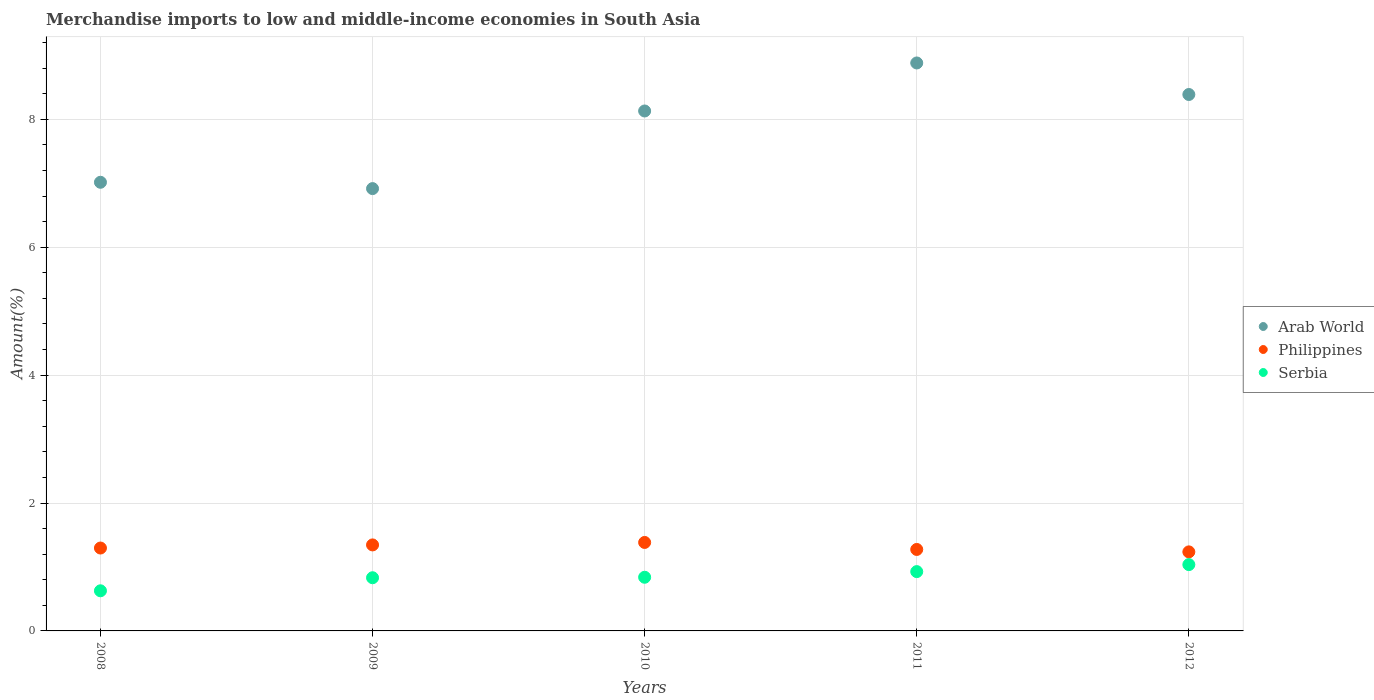How many different coloured dotlines are there?
Ensure brevity in your answer.  3. Is the number of dotlines equal to the number of legend labels?
Your answer should be compact. Yes. What is the percentage of amount earned from merchandise imports in Arab World in 2010?
Your answer should be compact. 8.13. Across all years, what is the maximum percentage of amount earned from merchandise imports in Arab World?
Keep it short and to the point. 8.88. Across all years, what is the minimum percentage of amount earned from merchandise imports in Serbia?
Your answer should be compact. 0.63. In which year was the percentage of amount earned from merchandise imports in Philippines maximum?
Offer a terse response. 2010. What is the total percentage of amount earned from merchandise imports in Arab World in the graph?
Your response must be concise. 39.33. What is the difference between the percentage of amount earned from merchandise imports in Philippines in 2009 and that in 2010?
Your answer should be compact. -0.04. What is the difference between the percentage of amount earned from merchandise imports in Philippines in 2010 and the percentage of amount earned from merchandise imports in Arab World in 2008?
Your answer should be compact. -5.63. What is the average percentage of amount earned from merchandise imports in Arab World per year?
Offer a very short reply. 7.87. In the year 2011, what is the difference between the percentage of amount earned from merchandise imports in Philippines and percentage of amount earned from merchandise imports in Serbia?
Make the answer very short. 0.35. What is the ratio of the percentage of amount earned from merchandise imports in Arab World in 2008 to that in 2009?
Keep it short and to the point. 1.01. Is the percentage of amount earned from merchandise imports in Philippines in 2008 less than that in 2011?
Give a very brief answer. No. Is the difference between the percentage of amount earned from merchandise imports in Philippines in 2008 and 2009 greater than the difference between the percentage of amount earned from merchandise imports in Serbia in 2008 and 2009?
Make the answer very short. Yes. What is the difference between the highest and the second highest percentage of amount earned from merchandise imports in Serbia?
Provide a succinct answer. 0.11. What is the difference between the highest and the lowest percentage of amount earned from merchandise imports in Philippines?
Make the answer very short. 0.15. Is the sum of the percentage of amount earned from merchandise imports in Philippines in 2008 and 2009 greater than the maximum percentage of amount earned from merchandise imports in Arab World across all years?
Make the answer very short. No. Is it the case that in every year, the sum of the percentage of amount earned from merchandise imports in Philippines and percentage of amount earned from merchandise imports in Arab World  is greater than the percentage of amount earned from merchandise imports in Serbia?
Provide a short and direct response. Yes. How many dotlines are there?
Make the answer very short. 3. What is the difference between two consecutive major ticks on the Y-axis?
Give a very brief answer. 2. Does the graph contain any zero values?
Make the answer very short. No. Where does the legend appear in the graph?
Provide a short and direct response. Center right. How many legend labels are there?
Provide a succinct answer. 3. What is the title of the graph?
Give a very brief answer. Merchandise imports to low and middle-income economies in South Asia. What is the label or title of the X-axis?
Your answer should be compact. Years. What is the label or title of the Y-axis?
Provide a short and direct response. Amount(%). What is the Amount(%) of Arab World in 2008?
Offer a very short reply. 7.01. What is the Amount(%) in Philippines in 2008?
Keep it short and to the point. 1.3. What is the Amount(%) of Serbia in 2008?
Offer a terse response. 0.63. What is the Amount(%) of Arab World in 2009?
Provide a short and direct response. 6.92. What is the Amount(%) in Philippines in 2009?
Ensure brevity in your answer.  1.34. What is the Amount(%) of Serbia in 2009?
Make the answer very short. 0.83. What is the Amount(%) of Arab World in 2010?
Your answer should be very brief. 8.13. What is the Amount(%) of Philippines in 2010?
Your response must be concise. 1.38. What is the Amount(%) in Serbia in 2010?
Make the answer very short. 0.84. What is the Amount(%) in Arab World in 2011?
Give a very brief answer. 8.88. What is the Amount(%) of Philippines in 2011?
Your response must be concise. 1.27. What is the Amount(%) of Serbia in 2011?
Provide a short and direct response. 0.93. What is the Amount(%) of Arab World in 2012?
Ensure brevity in your answer.  8.39. What is the Amount(%) in Philippines in 2012?
Provide a succinct answer. 1.24. What is the Amount(%) in Serbia in 2012?
Provide a succinct answer. 1.04. Across all years, what is the maximum Amount(%) of Arab World?
Keep it short and to the point. 8.88. Across all years, what is the maximum Amount(%) of Philippines?
Your answer should be very brief. 1.38. Across all years, what is the maximum Amount(%) in Serbia?
Ensure brevity in your answer.  1.04. Across all years, what is the minimum Amount(%) in Arab World?
Provide a short and direct response. 6.92. Across all years, what is the minimum Amount(%) of Philippines?
Make the answer very short. 1.24. Across all years, what is the minimum Amount(%) of Serbia?
Give a very brief answer. 0.63. What is the total Amount(%) of Arab World in the graph?
Provide a succinct answer. 39.33. What is the total Amount(%) of Philippines in the graph?
Your answer should be compact. 6.53. What is the total Amount(%) in Serbia in the graph?
Offer a very short reply. 4.26. What is the difference between the Amount(%) in Arab World in 2008 and that in 2009?
Your answer should be very brief. 0.1. What is the difference between the Amount(%) of Philippines in 2008 and that in 2009?
Keep it short and to the point. -0.05. What is the difference between the Amount(%) of Serbia in 2008 and that in 2009?
Make the answer very short. -0.2. What is the difference between the Amount(%) in Arab World in 2008 and that in 2010?
Ensure brevity in your answer.  -1.11. What is the difference between the Amount(%) of Philippines in 2008 and that in 2010?
Keep it short and to the point. -0.09. What is the difference between the Amount(%) in Serbia in 2008 and that in 2010?
Offer a very short reply. -0.21. What is the difference between the Amount(%) in Arab World in 2008 and that in 2011?
Provide a succinct answer. -1.87. What is the difference between the Amount(%) in Philippines in 2008 and that in 2011?
Your answer should be very brief. 0.02. What is the difference between the Amount(%) of Arab World in 2008 and that in 2012?
Provide a short and direct response. -1.37. What is the difference between the Amount(%) of Philippines in 2008 and that in 2012?
Offer a very short reply. 0.06. What is the difference between the Amount(%) in Serbia in 2008 and that in 2012?
Keep it short and to the point. -0.41. What is the difference between the Amount(%) in Arab World in 2009 and that in 2010?
Make the answer very short. -1.21. What is the difference between the Amount(%) in Philippines in 2009 and that in 2010?
Offer a terse response. -0.04. What is the difference between the Amount(%) in Serbia in 2009 and that in 2010?
Your answer should be compact. -0.01. What is the difference between the Amount(%) of Arab World in 2009 and that in 2011?
Keep it short and to the point. -1.96. What is the difference between the Amount(%) in Philippines in 2009 and that in 2011?
Make the answer very short. 0.07. What is the difference between the Amount(%) in Serbia in 2009 and that in 2011?
Your response must be concise. -0.1. What is the difference between the Amount(%) of Arab World in 2009 and that in 2012?
Your answer should be very brief. -1.47. What is the difference between the Amount(%) of Philippines in 2009 and that in 2012?
Your response must be concise. 0.11. What is the difference between the Amount(%) of Serbia in 2009 and that in 2012?
Your answer should be compact. -0.21. What is the difference between the Amount(%) in Arab World in 2010 and that in 2011?
Ensure brevity in your answer.  -0.75. What is the difference between the Amount(%) in Philippines in 2010 and that in 2011?
Your answer should be very brief. 0.11. What is the difference between the Amount(%) in Serbia in 2010 and that in 2011?
Give a very brief answer. -0.09. What is the difference between the Amount(%) of Arab World in 2010 and that in 2012?
Provide a succinct answer. -0.26. What is the difference between the Amount(%) of Philippines in 2010 and that in 2012?
Your response must be concise. 0.15. What is the difference between the Amount(%) of Serbia in 2010 and that in 2012?
Your answer should be compact. -0.2. What is the difference between the Amount(%) of Arab World in 2011 and that in 2012?
Offer a very short reply. 0.49. What is the difference between the Amount(%) of Philippines in 2011 and that in 2012?
Your answer should be compact. 0.04. What is the difference between the Amount(%) in Serbia in 2011 and that in 2012?
Ensure brevity in your answer.  -0.11. What is the difference between the Amount(%) in Arab World in 2008 and the Amount(%) in Philippines in 2009?
Make the answer very short. 5.67. What is the difference between the Amount(%) in Arab World in 2008 and the Amount(%) in Serbia in 2009?
Make the answer very short. 6.18. What is the difference between the Amount(%) of Philippines in 2008 and the Amount(%) of Serbia in 2009?
Provide a succinct answer. 0.46. What is the difference between the Amount(%) of Arab World in 2008 and the Amount(%) of Philippines in 2010?
Provide a succinct answer. 5.63. What is the difference between the Amount(%) of Arab World in 2008 and the Amount(%) of Serbia in 2010?
Offer a very short reply. 6.18. What is the difference between the Amount(%) of Philippines in 2008 and the Amount(%) of Serbia in 2010?
Keep it short and to the point. 0.46. What is the difference between the Amount(%) in Arab World in 2008 and the Amount(%) in Philippines in 2011?
Keep it short and to the point. 5.74. What is the difference between the Amount(%) in Arab World in 2008 and the Amount(%) in Serbia in 2011?
Make the answer very short. 6.09. What is the difference between the Amount(%) of Philippines in 2008 and the Amount(%) of Serbia in 2011?
Make the answer very short. 0.37. What is the difference between the Amount(%) in Arab World in 2008 and the Amount(%) in Philippines in 2012?
Your answer should be compact. 5.78. What is the difference between the Amount(%) in Arab World in 2008 and the Amount(%) in Serbia in 2012?
Your answer should be very brief. 5.98. What is the difference between the Amount(%) of Philippines in 2008 and the Amount(%) of Serbia in 2012?
Keep it short and to the point. 0.26. What is the difference between the Amount(%) in Arab World in 2009 and the Amount(%) in Philippines in 2010?
Provide a short and direct response. 5.53. What is the difference between the Amount(%) in Arab World in 2009 and the Amount(%) in Serbia in 2010?
Your answer should be compact. 6.08. What is the difference between the Amount(%) of Philippines in 2009 and the Amount(%) of Serbia in 2010?
Ensure brevity in your answer.  0.51. What is the difference between the Amount(%) in Arab World in 2009 and the Amount(%) in Philippines in 2011?
Give a very brief answer. 5.64. What is the difference between the Amount(%) of Arab World in 2009 and the Amount(%) of Serbia in 2011?
Provide a short and direct response. 5.99. What is the difference between the Amount(%) in Philippines in 2009 and the Amount(%) in Serbia in 2011?
Provide a short and direct response. 0.42. What is the difference between the Amount(%) in Arab World in 2009 and the Amount(%) in Philippines in 2012?
Give a very brief answer. 5.68. What is the difference between the Amount(%) of Arab World in 2009 and the Amount(%) of Serbia in 2012?
Your answer should be compact. 5.88. What is the difference between the Amount(%) in Philippines in 2009 and the Amount(%) in Serbia in 2012?
Make the answer very short. 0.31. What is the difference between the Amount(%) in Arab World in 2010 and the Amount(%) in Philippines in 2011?
Make the answer very short. 6.86. What is the difference between the Amount(%) in Arab World in 2010 and the Amount(%) in Serbia in 2011?
Provide a short and direct response. 7.2. What is the difference between the Amount(%) of Philippines in 2010 and the Amount(%) of Serbia in 2011?
Give a very brief answer. 0.46. What is the difference between the Amount(%) in Arab World in 2010 and the Amount(%) in Philippines in 2012?
Your response must be concise. 6.89. What is the difference between the Amount(%) of Arab World in 2010 and the Amount(%) of Serbia in 2012?
Ensure brevity in your answer.  7.09. What is the difference between the Amount(%) in Philippines in 2010 and the Amount(%) in Serbia in 2012?
Offer a terse response. 0.35. What is the difference between the Amount(%) in Arab World in 2011 and the Amount(%) in Philippines in 2012?
Offer a very short reply. 7.64. What is the difference between the Amount(%) of Arab World in 2011 and the Amount(%) of Serbia in 2012?
Keep it short and to the point. 7.84. What is the difference between the Amount(%) in Philippines in 2011 and the Amount(%) in Serbia in 2012?
Offer a very short reply. 0.24. What is the average Amount(%) of Arab World per year?
Your answer should be compact. 7.87. What is the average Amount(%) in Philippines per year?
Provide a short and direct response. 1.31. What is the average Amount(%) in Serbia per year?
Your answer should be compact. 0.85. In the year 2008, what is the difference between the Amount(%) in Arab World and Amount(%) in Philippines?
Your response must be concise. 5.72. In the year 2008, what is the difference between the Amount(%) of Arab World and Amount(%) of Serbia?
Keep it short and to the point. 6.39. In the year 2008, what is the difference between the Amount(%) of Philippines and Amount(%) of Serbia?
Keep it short and to the point. 0.67. In the year 2009, what is the difference between the Amount(%) of Arab World and Amount(%) of Philippines?
Keep it short and to the point. 5.57. In the year 2009, what is the difference between the Amount(%) in Arab World and Amount(%) in Serbia?
Ensure brevity in your answer.  6.08. In the year 2009, what is the difference between the Amount(%) of Philippines and Amount(%) of Serbia?
Ensure brevity in your answer.  0.51. In the year 2010, what is the difference between the Amount(%) in Arab World and Amount(%) in Philippines?
Offer a terse response. 6.75. In the year 2010, what is the difference between the Amount(%) in Arab World and Amount(%) in Serbia?
Provide a short and direct response. 7.29. In the year 2010, what is the difference between the Amount(%) in Philippines and Amount(%) in Serbia?
Offer a very short reply. 0.54. In the year 2011, what is the difference between the Amount(%) of Arab World and Amount(%) of Philippines?
Provide a short and direct response. 7.61. In the year 2011, what is the difference between the Amount(%) in Arab World and Amount(%) in Serbia?
Provide a succinct answer. 7.95. In the year 2011, what is the difference between the Amount(%) in Philippines and Amount(%) in Serbia?
Offer a terse response. 0.35. In the year 2012, what is the difference between the Amount(%) in Arab World and Amount(%) in Philippines?
Your answer should be compact. 7.15. In the year 2012, what is the difference between the Amount(%) of Arab World and Amount(%) of Serbia?
Your answer should be very brief. 7.35. In the year 2012, what is the difference between the Amount(%) in Philippines and Amount(%) in Serbia?
Provide a short and direct response. 0.2. What is the ratio of the Amount(%) of Arab World in 2008 to that in 2009?
Offer a terse response. 1.01. What is the ratio of the Amount(%) of Philippines in 2008 to that in 2009?
Your answer should be very brief. 0.96. What is the ratio of the Amount(%) in Serbia in 2008 to that in 2009?
Provide a short and direct response. 0.75. What is the ratio of the Amount(%) of Arab World in 2008 to that in 2010?
Ensure brevity in your answer.  0.86. What is the ratio of the Amount(%) in Philippines in 2008 to that in 2010?
Make the answer very short. 0.94. What is the ratio of the Amount(%) in Serbia in 2008 to that in 2010?
Offer a very short reply. 0.75. What is the ratio of the Amount(%) of Arab World in 2008 to that in 2011?
Offer a terse response. 0.79. What is the ratio of the Amount(%) of Philippines in 2008 to that in 2011?
Your answer should be very brief. 1.02. What is the ratio of the Amount(%) in Serbia in 2008 to that in 2011?
Ensure brevity in your answer.  0.68. What is the ratio of the Amount(%) in Arab World in 2008 to that in 2012?
Provide a succinct answer. 0.84. What is the ratio of the Amount(%) of Philippines in 2008 to that in 2012?
Offer a terse response. 1.05. What is the ratio of the Amount(%) of Serbia in 2008 to that in 2012?
Offer a terse response. 0.61. What is the ratio of the Amount(%) of Arab World in 2009 to that in 2010?
Provide a succinct answer. 0.85. What is the ratio of the Amount(%) in Philippines in 2009 to that in 2010?
Provide a succinct answer. 0.97. What is the ratio of the Amount(%) of Arab World in 2009 to that in 2011?
Make the answer very short. 0.78. What is the ratio of the Amount(%) in Philippines in 2009 to that in 2011?
Offer a terse response. 1.06. What is the ratio of the Amount(%) in Serbia in 2009 to that in 2011?
Ensure brevity in your answer.  0.9. What is the ratio of the Amount(%) in Arab World in 2009 to that in 2012?
Provide a short and direct response. 0.82. What is the ratio of the Amount(%) of Philippines in 2009 to that in 2012?
Make the answer very short. 1.09. What is the ratio of the Amount(%) in Serbia in 2009 to that in 2012?
Your answer should be compact. 0.8. What is the ratio of the Amount(%) in Arab World in 2010 to that in 2011?
Provide a succinct answer. 0.92. What is the ratio of the Amount(%) of Philippines in 2010 to that in 2011?
Your answer should be very brief. 1.09. What is the ratio of the Amount(%) in Serbia in 2010 to that in 2011?
Make the answer very short. 0.9. What is the ratio of the Amount(%) of Arab World in 2010 to that in 2012?
Your answer should be compact. 0.97. What is the ratio of the Amount(%) in Philippines in 2010 to that in 2012?
Offer a very short reply. 1.12. What is the ratio of the Amount(%) in Serbia in 2010 to that in 2012?
Keep it short and to the point. 0.81. What is the ratio of the Amount(%) of Arab World in 2011 to that in 2012?
Offer a terse response. 1.06. What is the ratio of the Amount(%) in Philippines in 2011 to that in 2012?
Ensure brevity in your answer.  1.03. What is the ratio of the Amount(%) of Serbia in 2011 to that in 2012?
Provide a short and direct response. 0.89. What is the difference between the highest and the second highest Amount(%) in Arab World?
Offer a very short reply. 0.49. What is the difference between the highest and the second highest Amount(%) of Philippines?
Make the answer very short. 0.04. What is the difference between the highest and the second highest Amount(%) in Serbia?
Give a very brief answer. 0.11. What is the difference between the highest and the lowest Amount(%) in Arab World?
Your answer should be very brief. 1.96. What is the difference between the highest and the lowest Amount(%) of Philippines?
Your answer should be compact. 0.15. What is the difference between the highest and the lowest Amount(%) of Serbia?
Ensure brevity in your answer.  0.41. 